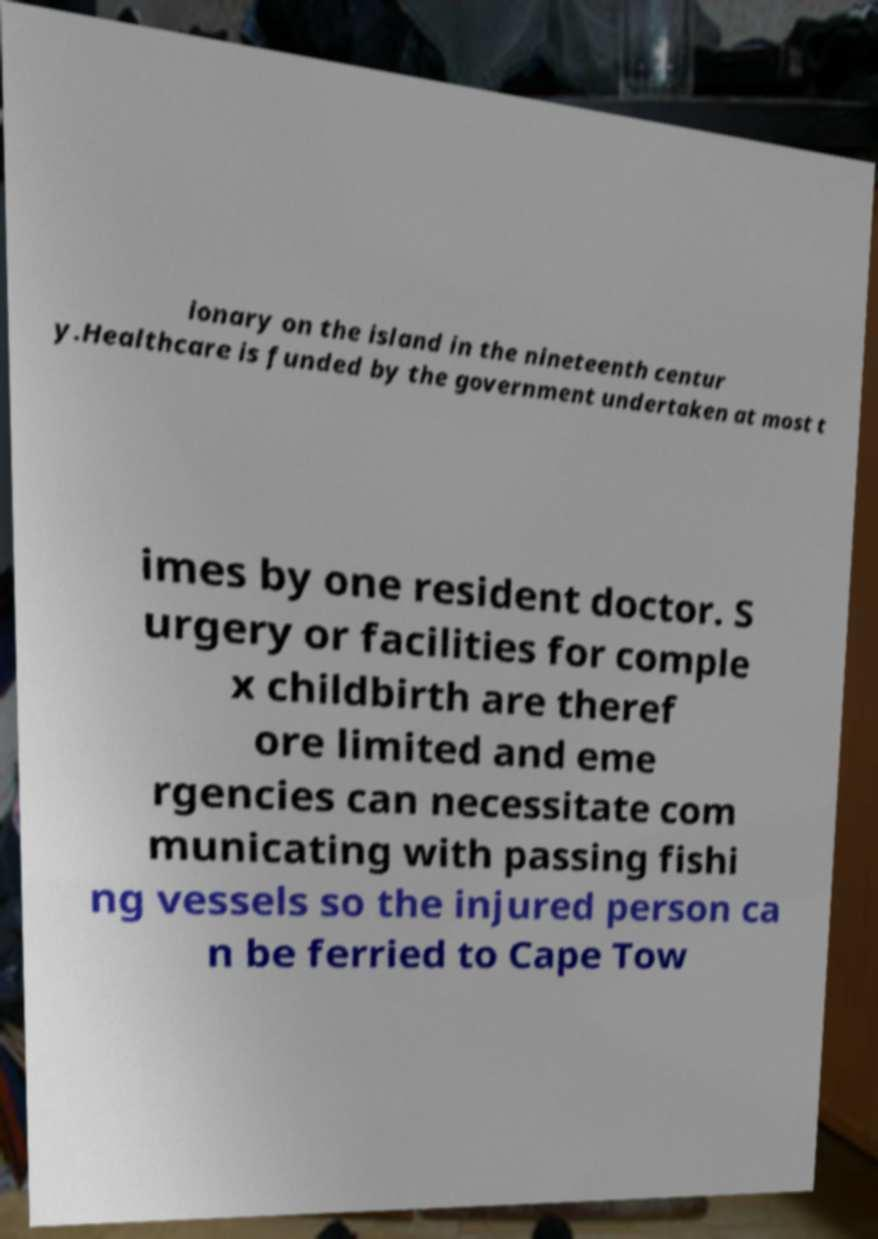Could you extract and type out the text from this image? ionary on the island in the nineteenth centur y.Healthcare is funded by the government undertaken at most t imes by one resident doctor. S urgery or facilities for comple x childbirth are theref ore limited and eme rgencies can necessitate com municating with passing fishi ng vessels so the injured person ca n be ferried to Cape Tow 